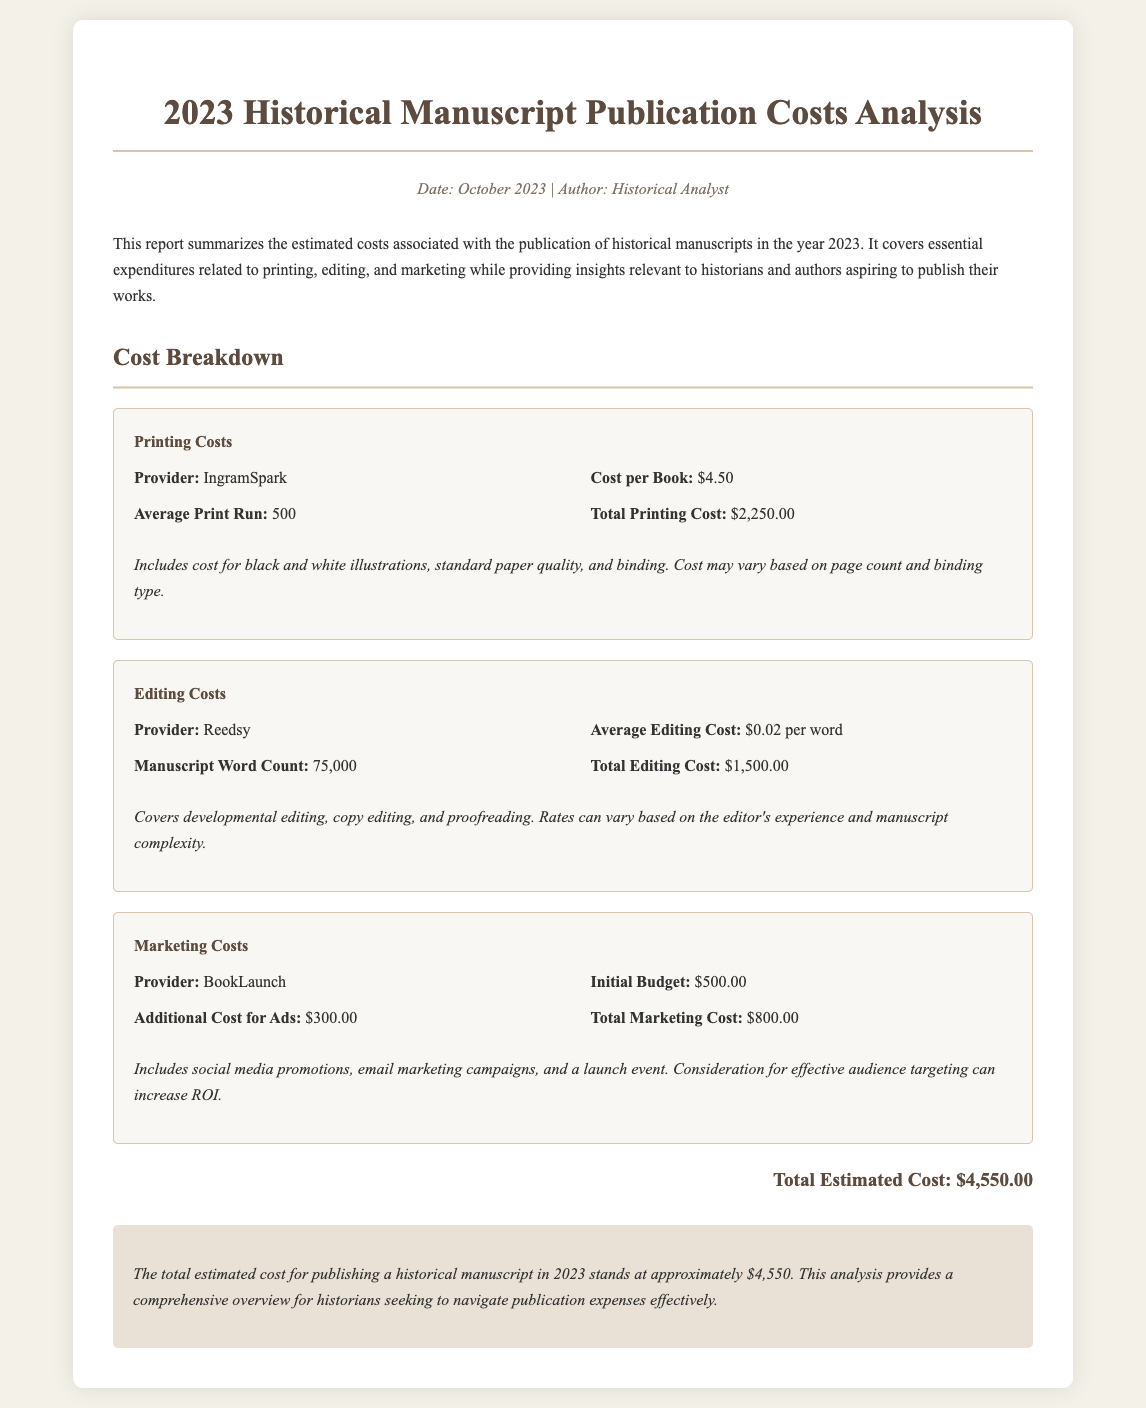What is the printing cost per book? The printing cost per book listed in the document is $4.50.
Answer: $4.50 What is the total printing cost? The total printing cost is stated as $2,250.00.
Answer: $2,250.00 How many words is the manuscript? The manuscript word count mentioned in the document is 75,000 words.
Answer: 75,000 What is the total marketing cost? The document provides the total marketing cost as $800.00.
Answer: $800.00 Who is the editing provider? The provider for editing services listed in the document is Reedsy.
Answer: Reedsy What is the initial budget for marketing? The initial budget for marketing is noted as $500.00.
Answer: $500.00 What is the total estimated publication cost? The total estimated cost for publishing is summarized as $4,550.00.
Answer: $4,550.00 Which company provides printing services? The provider for printing services mentioned is IngramSpark.
Answer: IngramSpark What type of editing is covered in the costs? The document states that developmental editing, copy editing, and proofreading are included.
Answer: Developmental editing, copy editing, and proofreading 